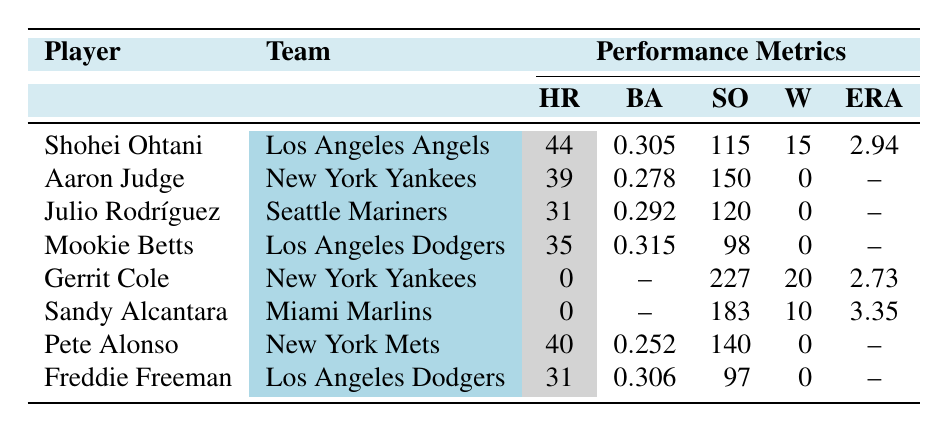What is the highest number of home runs hit by a player in the table? The table shows that the player with the highest number of home runs is Shohei Ohtani with 44 home runs.
Answer: 44 Which player has the lowest earned run average? The lowest earned run average from the pitchers in the table is Gerrit Cole, with an ERA of 2.73.
Answer: 2.73 How many players have a batting average greater than 0.300? By checking the batting average column, Shohei Ohtani (0.305), Mookie Betts (0.315), and Freddie Freeman (0.306) have averages above 0.300. That makes it a total of 3 players.
Answer: 3 What is the combined total of wins for all players listed in the table? Adding the wins, we have: Ohtani (15) + Gerrit Cole (20) + Sandy Alcantara (10) = 45. The other players have 0 wins. Thus, the combined total of wins is 45.
Answer: 45 Is there a player in the table who has both a high number of strikeouts and wins? Yes, Gerrit Cole has 227 strikeouts and 20 wins, indicating high performance as a pitcher.
Answer: Yes Who among the players has the most strikeouts and what is the number? The player with the most strikeouts is Gerrit Cole with 227 strikeouts.
Answer: 227 Which player has the lowest batting average, and what is that average? The player with the lowest batting average is Pete Alonso, with a batting average of 0.252.
Answer: 0.252 If Mookie Betts and Shohei Ohtani had their home runs added together, what would that total be? Adding their home runs: Mookie Betts (35) + Shohei Ohtani (44) gives a total of 79 home runs.
Answer: 79 What percentage of the players in the table are pitchers? There are 2 pitchers (Gerrit Cole and Sandy Alcantara) out of 8 total players, which is (2/8) * 100 = 25%.
Answer: 25% 